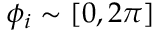Convert formula to latex. <formula><loc_0><loc_0><loc_500><loc_500>\phi _ { i } \sim [ 0 , 2 \pi ]</formula> 